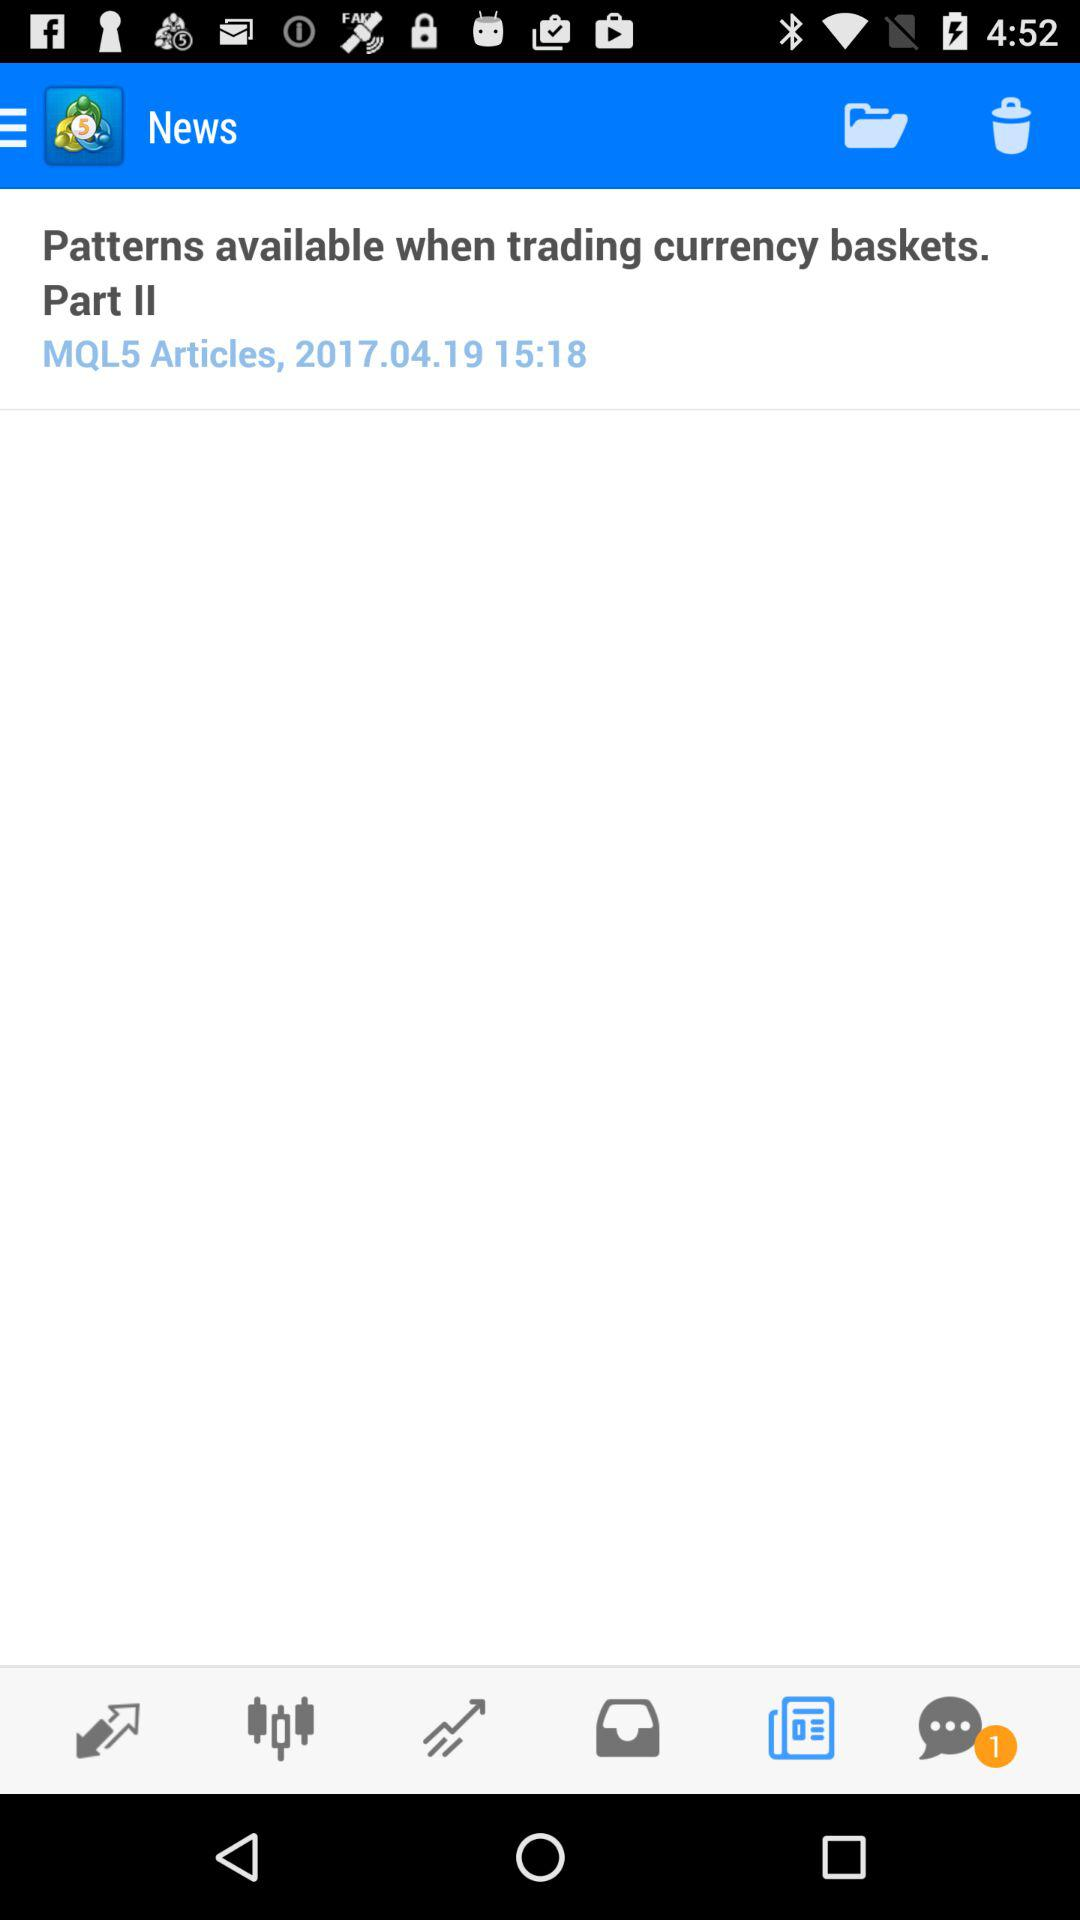How many notifications are there in "Messages" tab? There is 1 notification. 